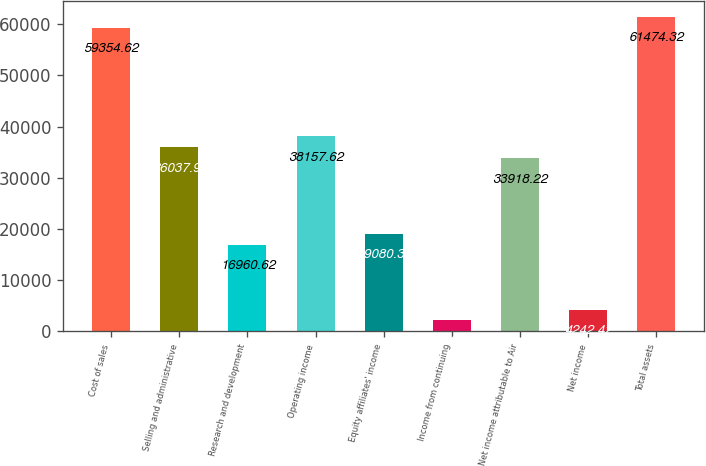<chart> <loc_0><loc_0><loc_500><loc_500><bar_chart><fcel>Cost of sales<fcel>Selling and administrative<fcel>Research and development<fcel>Operating income<fcel>Equity affiliates' income<fcel>Income from continuing<fcel>Net income attributable to Air<fcel>Net income<fcel>Total assets<nl><fcel>59354.6<fcel>36037.9<fcel>16960.6<fcel>38157.6<fcel>19080.3<fcel>2122.72<fcel>33918.2<fcel>4242.42<fcel>61474.3<nl></chart> 